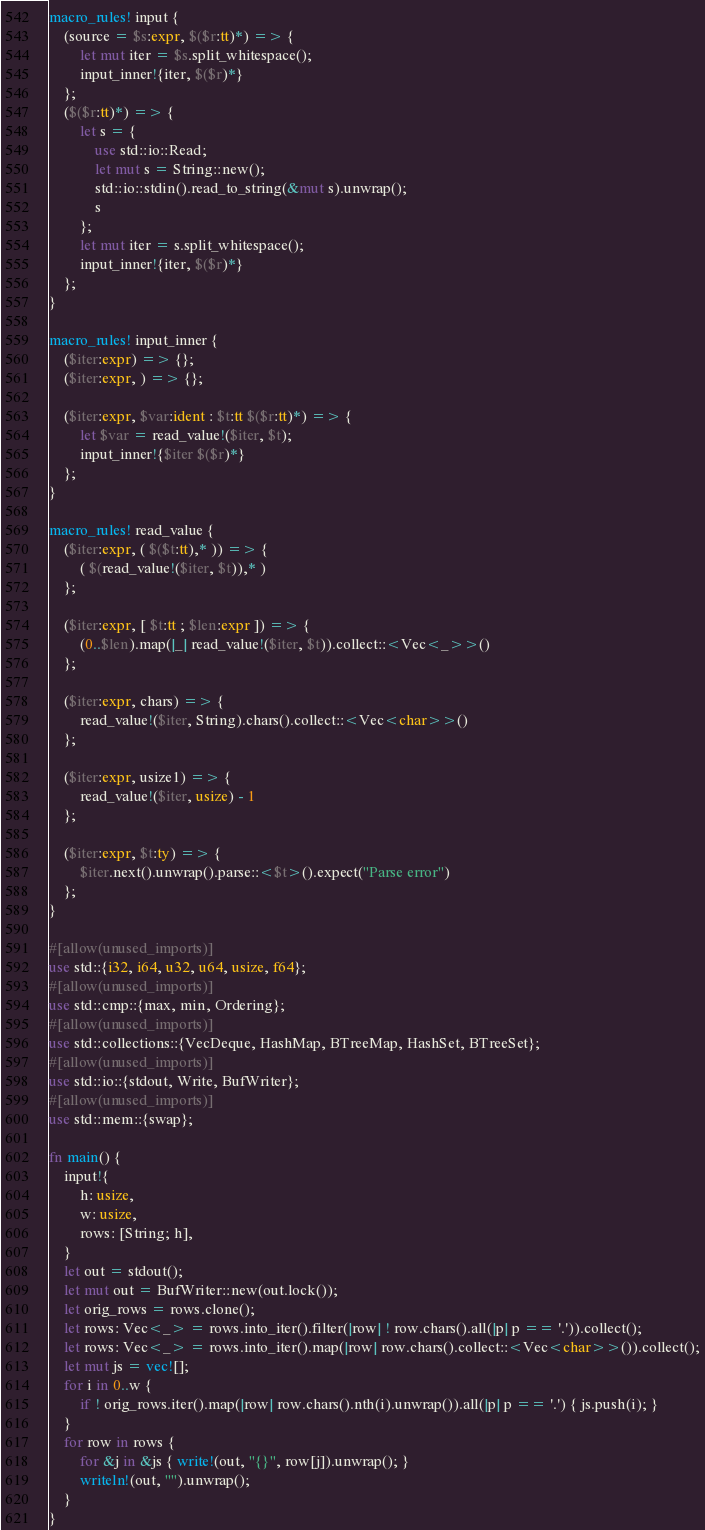Convert code to text. <code><loc_0><loc_0><loc_500><loc_500><_Rust_>macro_rules! input {
    (source = $s:expr, $($r:tt)*) => {
        let mut iter = $s.split_whitespace();
        input_inner!{iter, $($r)*}
    };
    ($($r:tt)*) => {
        let s = {
            use std::io::Read;
            let mut s = String::new();
            std::io::stdin().read_to_string(&mut s).unwrap();
            s
        };
        let mut iter = s.split_whitespace();
        input_inner!{iter, $($r)*}
    };
}

macro_rules! input_inner {
    ($iter:expr) => {};
    ($iter:expr, ) => {};

    ($iter:expr, $var:ident : $t:tt $($r:tt)*) => {
        let $var = read_value!($iter, $t);
        input_inner!{$iter $($r)*}
    };
}

macro_rules! read_value {
    ($iter:expr, ( $($t:tt),* )) => {
        ( $(read_value!($iter, $t)),* )
    };

    ($iter:expr, [ $t:tt ; $len:expr ]) => {
        (0..$len).map(|_| read_value!($iter, $t)).collect::<Vec<_>>()
    };

    ($iter:expr, chars) => {
        read_value!($iter, String).chars().collect::<Vec<char>>()
    };

    ($iter:expr, usize1) => {
        read_value!($iter, usize) - 1
    };

    ($iter:expr, $t:ty) => {
        $iter.next().unwrap().parse::<$t>().expect("Parse error")
    };
}

#[allow(unused_imports)]
use std::{i32, i64, u32, u64, usize, f64};
#[allow(unused_imports)]
use std::cmp::{max, min, Ordering};
#[allow(unused_imports)]
use std::collections::{VecDeque, HashMap, BTreeMap, HashSet, BTreeSet};
#[allow(unused_imports)]
use std::io::{stdout, Write, BufWriter};
#[allow(unused_imports)]
use std::mem::{swap};

fn main() {
    input!{
        h: usize,
        w: usize,
        rows: [String; h],
    }
    let out = stdout();
    let mut out = BufWriter::new(out.lock());
    let orig_rows = rows.clone();
    let rows: Vec<_> = rows.into_iter().filter(|row| ! row.chars().all(|p| p == '.')).collect();
    let rows: Vec<_> = rows.into_iter().map(|row| row.chars().collect::<Vec<char>>()).collect();
    let mut js = vec![];
    for i in 0..w {
        if ! orig_rows.iter().map(|row| row.chars().nth(i).unwrap()).all(|p| p == '.') { js.push(i); }
    }
    for row in rows {
        for &j in &js { write!(out, "{}", row[j]).unwrap(); }
        writeln!(out, "").unwrap();
    }
}
</code> 